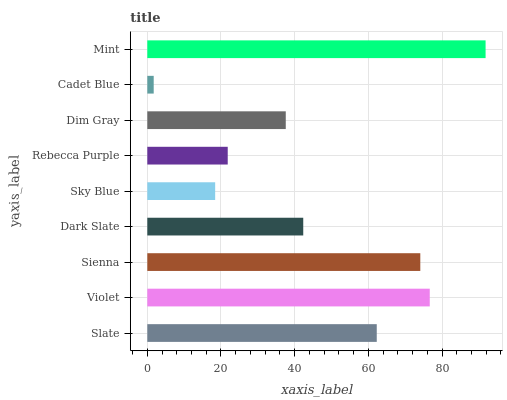Is Cadet Blue the minimum?
Answer yes or no. Yes. Is Mint the maximum?
Answer yes or no. Yes. Is Violet the minimum?
Answer yes or no. No. Is Violet the maximum?
Answer yes or no. No. Is Violet greater than Slate?
Answer yes or no. Yes. Is Slate less than Violet?
Answer yes or no. Yes. Is Slate greater than Violet?
Answer yes or no. No. Is Violet less than Slate?
Answer yes or no. No. Is Dark Slate the high median?
Answer yes or no. Yes. Is Dark Slate the low median?
Answer yes or no. Yes. Is Rebecca Purple the high median?
Answer yes or no. No. Is Violet the low median?
Answer yes or no. No. 